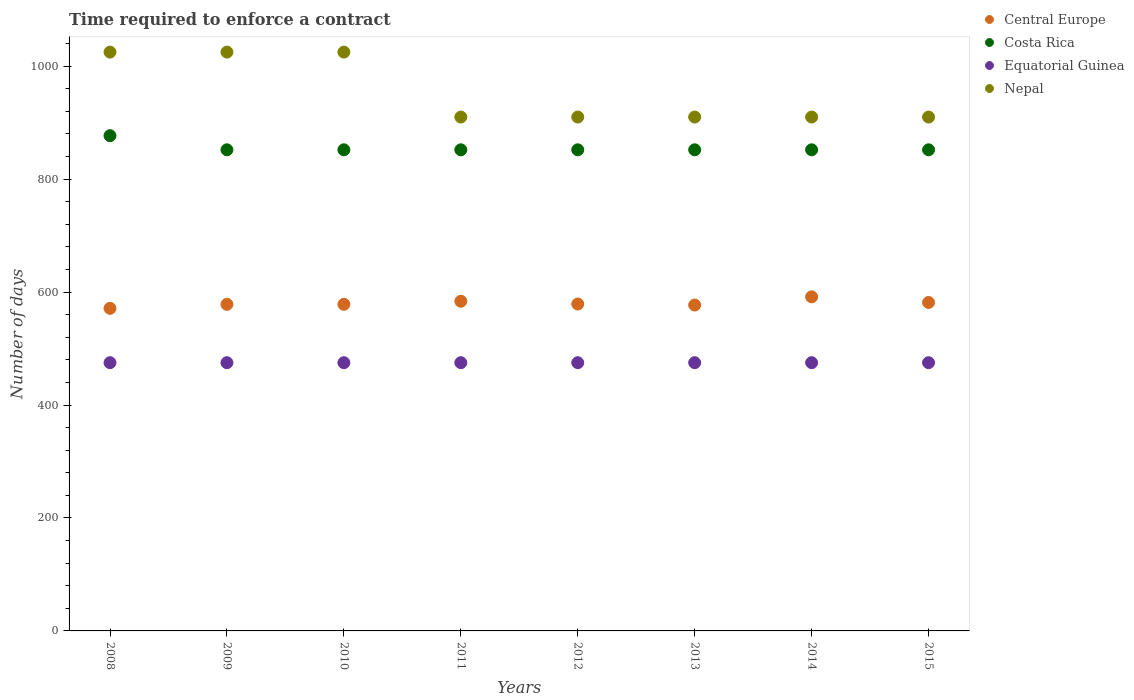How many different coloured dotlines are there?
Give a very brief answer. 4. Is the number of dotlines equal to the number of legend labels?
Keep it short and to the point. Yes. What is the number of days required to enforce a contract in Nepal in 2008?
Make the answer very short. 1025. Across all years, what is the maximum number of days required to enforce a contract in Nepal?
Provide a short and direct response. 1025. Across all years, what is the minimum number of days required to enforce a contract in Nepal?
Keep it short and to the point. 910. What is the total number of days required to enforce a contract in Equatorial Guinea in the graph?
Make the answer very short. 3800. What is the difference between the number of days required to enforce a contract in Costa Rica in 2012 and the number of days required to enforce a contract in Nepal in 2008?
Make the answer very short. -173. What is the average number of days required to enforce a contract in Equatorial Guinea per year?
Offer a terse response. 475. In the year 2015, what is the difference between the number of days required to enforce a contract in Central Europe and number of days required to enforce a contract in Costa Rica?
Your answer should be very brief. -270.36. In how many years, is the number of days required to enforce a contract in Nepal greater than 520 days?
Provide a short and direct response. 8. What is the ratio of the number of days required to enforce a contract in Central Europe in 2010 to that in 2012?
Provide a short and direct response. 1. What is the difference between the highest and the second highest number of days required to enforce a contract in Costa Rica?
Your answer should be compact. 25. What is the difference between the highest and the lowest number of days required to enforce a contract in Nepal?
Offer a terse response. 115. In how many years, is the number of days required to enforce a contract in Costa Rica greater than the average number of days required to enforce a contract in Costa Rica taken over all years?
Provide a short and direct response. 1. Is it the case that in every year, the sum of the number of days required to enforce a contract in Equatorial Guinea and number of days required to enforce a contract in Nepal  is greater than the number of days required to enforce a contract in Central Europe?
Your answer should be compact. Yes. Does the number of days required to enforce a contract in Central Europe monotonically increase over the years?
Make the answer very short. No. Is the number of days required to enforce a contract in Central Europe strictly greater than the number of days required to enforce a contract in Equatorial Guinea over the years?
Ensure brevity in your answer.  Yes. Is the number of days required to enforce a contract in Costa Rica strictly less than the number of days required to enforce a contract in Equatorial Guinea over the years?
Give a very brief answer. No. How many dotlines are there?
Make the answer very short. 4. What is the difference between two consecutive major ticks on the Y-axis?
Make the answer very short. 200. Where does the legend appear in the graph?
Give a very brief answer. Top right. How many legend labels are there?
Give a very brief answer. 4. How are the legend labels stacked?
Your answer should be very brief. Vertical. What is the title of the graph?
Give a very brief answer. Time required to enforce a contract. Does "New Zealand" appear as one of the legend labels in the graph?
Keep it short and to the point. No. What is the label or title of the Y-axis?
Your response must be concise. Number of days. What is the Number of days in Central Europe in 2008?
Offer a very short reply. 571.27. What is the Number of days in Costa Rica in 2008?
Make the answer very short. 877. What is the Number of days of Equatorial Guinea in 2008?
Provide a succinct answer. 475. What is the Number of days of Nepal in 2008?
Your response must be concise. 1025. What is the Number of days in Central Europe in 2009?
Provide a succinct answer. 578.36. What is the Number of days in Costa Rica in 2009?
Your response must be concise. 852. What is the Number of days in Equatorial Guinea in 2009?
Give a very brief answer. 475. What is the Number of days of Nepal in 2009?
Give a very brief answer. 1025. What is the Number of days of Central Europe in 2010?
Give a very brief answer. 578.36. What is the Number of days of Costa Rica in 2010?
Offer a very short reply. 852. What is the Number of days in Equatorial Guinea in 2010?
Your answer should be compact. 475. What is the Number of days in Nepal in 2010?
Keep it short and to the point. 1025. What is the Number of days of Central Europe in 2011?
Offer a very short reply. 583.82. What is the Number of days of Costa Rica in 2011?
Ensure brevity in your answer.  852. What is the Number of days of Equatorial Guinea in 2011?
Your answer should be very brief. 475. What is the Number of days in Nepal in 2011?
Offer a very short reply. 910. What is the Number of days of Central Europe in 2012?
Keep it short and to the point. 578.91. What is the Number of days in Costa Rica in 2012?
Provide a succinct answer. 852. What is the Number of days in Equatorial Guinea in 2012?
Keep it short and to the point. 475. What is the Number of days of Nepal in 2012?
Make the answer very short. 910. What is the Number of days in Central Europe in 2013?
Keep it short and to the point. 577.09. What is the Number of days in Costa Rica in 2013?
Give a very brief answer. 852. What is the Number of days of Equatorial Guinea in 2013?
Your answer should be compact. 475. What is the Number of days of Nepal in 2013?
Your answer should be very brief. 910. What is the Number of days in Central Europe in 2014?
Offer a very short reply. 591.64. What is the Number of days in Costa Rica in 2014?
Ensure brevity in your answer.  852. What is the Number of days in Equatorial Guinea in 2014?
Provide a succinct answer. 475. What is the Number of days of Nepal in 2014?
Provide a short and direct response. 910. What is the Number of days in Central Europe in 2015?
Your answer should be very brief. 581.64. What is the Number of days in Costa Rica in 2015?
Keep it short and to the point. 852. What is the Number of days of Equatorial Guinea in 2015?
Provide a succinct answer. 475. What is the Number of days of Nepal in 2015?
Your answer should be very brief. 910. Across all years, what is the maximum Number of days in Central Europe?
Your answer should be very brief. 591.64. Across all years, what is the maximum Number of days of Costa Rica?
Offer a terse response. 877. Across all years, what is the maximum Number of days of Equatorial Guinea?
Provide a short and direct response. 475. Across all years, what is the maximum Number of days of Nepal?
Your response must be concise. 1025. Across all years, what is the minimum Number of days of Central Europe?
Provide a short and direct response. 571.27. Across all years, what is the minimum Number of days in Costa Rica?
Make the answer very short. 852. Across all years, what is the minimum Number of days in Equatorial Guinea?
Your answer should be compact. 475. Across all years, what is the minimum Number of days of Nepal?
Provide a succinct answer. 910. What is the total Number of days of Central Europe in the graph?
Ensure brevity in your answer.  4641.09. What is the total Number of days in Costa Rica in the graph?
Ensure brevity in your answer.  6841. What is the total Number of days in Equatorial Guinea in the graph?
Your answer should be very brief. 3800. What is the total Number of days in Nepal in the graph?
Keep it short and to the point. 7625. What is the difference between the Number of days in Central Europe in 2008 and that in 2009?
Your response must be concise. -7.09. What is the difference between the Number of days of Equatorial Guinea in 2008 and that in 2009?
Your answer should be very brief. 0. What is the difference between the Number of days in Central Europe in 2008 and that in 2010?
Make the answer very short. -7.09. What is the difference between the Number of days in Costa Rica in 2008 and that in 2010?
Give a very brief answer. 25. What is the difference between the Number of days of Equatorial Guinea in 2008 and that in 2010?
Offer a very short reply. 0. What is the difference between the Number of days in Central Europe in 2008 and that in 2011?
Keep it short and to the point. -12.55. What is the difference between the Number of days in Costa Rica in 2008 and that in 2011?
Your response must be concise. 25. What is the difference between the Number of days in Equatorial Guinea in 2008 and that in 2011?
Make the answer very short. 0. What is the difference between the Number of days of Nepal in 2008 and that in 2011?
Provide a succinct answer. 115. What is the difference between the Number of days in Central Europe in 2008 and that in 2012?
Offer a terse response. -7.64. What is the difference between the Number of days in Costa Rica in 2008 and that in 2012?
Provide a short and direct response. 25. What is the difference between the Number of days of Nepal in 2008 and that in 2012?
Your answer should be very brief. 115. What is the difference between the Number of days of Central Europe in 2008 and that in 2013?
Provide a succinct answer. -5.82. What is the difference between the Number of days of Equatorial Guinea in 2008 and that in 2013?
Ensure brevity in your answer.  0. What is the difference between the Number of days of Nepal in 2008 and that in 2013?
Keep it short and to the point. 115. What is the difference between the Number of days in Central Europe in 2008 and that in 2014?
Your answer should be compact. -20.36. What is the difference between the Number of days in Costa Rica in 2008 and that in 2014?
Offer a terse response. 25. What is the difference between the Number of days of Equatorial Guinea in 2008 and that in 2014?
Your response must be concise. 0. What is the difference between the Number of days in Nepal in 2008 and that in 2014?
Make the answer very short. 115. What is the difference between the Number of days in Central Europe in 2008 and that in 2015?
Offer a terse response. -10.36. What is the difference between the Number of days of Costa Rica in 2008 and that in 2015?
Provide a succinct answer. 25. What is the difference between the Number of days in Equatorial Guinea in 2008 and that in 2015?
Offer a terse response. 0. What is the difference between the Number of days of Nepal in 2008 and that in 2015?
Your response must be concise. 115. What is the difference between the Number of days in Costa Rica in 2009 and that in 2010?
Your answer should be very brief. 0. What is the difference between the Number of days of Central Europe in 2009 and that in 2011?
Keep it short and to the point. -5.45. What is the difference between the Number of days in Equatorial Guinea in 2009 and that in 2011?
Provide a succinct answer. 0. What is the difference between the Number of days in Nepal in 2009 and that in 2011?
Your answer should be compact. 115. What is the difference between the Number of days of Central Europe in 2009 and that in 2012?
Provide a short and direct response. -0.55. What is the difference between the Number of days in Costa Rica in 2009 and that in 2012?
Make the answer very short. 0. What is the difference between the Number of days of Nepal in 2009 and that in 2012?
Ensure brevity in your answer.  115. What is the difference between the Number of days in Central Europe in 2009 and that in 2013?
Your answer should be compact. 1.27. What is the difference between the Number of days of Nepal in 2009 and that in 2013?
Provide a succinct answer. 115. What is the difference between the Number of days in Central Europe in 2009 and that in 2014?
Offer a very short reply. -13.27. What is the difference between the Number of days of Costa Rica in 2009 and that in 2014?
Offer a very short reply. 0. What is the difference between the Number of days in Equatorial Guinea in 2009 and that in 2014?
Your response must be concise. 0. What is the difference between the Number of days in Nepal in 2009 and that in 2014?
Provide a short and direct response. 115. What is the difference between the Number of days in Central Europe in 2009 and that in 2015?
Your answer should be compact. -3.27. What is the difference between the Number of days of Equatorial Guinea in 2009 and that in 2015?
Give a very brief answer. 0. What is the difference between the Number of days of Nepal in 2009 and that in 2015?
Provide a short and direct response. 115. What is the difference between the Number of days of Central Europe in 2010 and that in 2011?
Offer a very short reply. -5.45. What is the difference between the Number of days of Costa Rica in 2010 and that in 2011?
Provide a short and direct response. 0. What is the difference between the Number of days of Equatorial Guinea in 2010 and that in 2011?
Make the answer very short. 0. What is the difference between the Number of days of Nepal in 2010 and that in 2011?
Your response must be concise. 115. What is the difference between the Number of days in Central Europe in 2010 and that in 2012?
Offer a terse response. -0.55. What is the difference between the Number of days in Nepal in 2010 and that in 2012?
Offer a terse response. 115. What is the difference between the Number of days of Central Europe in 2010 and that in 2013?
Offer a terse response. 1.27. What is the difference between the Number of days in Nepal in 2010 and that in 2013?
Provide a succinct answer. 115. What is the difference between the Number of days of Central Europe in 2010 and that in 2014?
Offer a very short reply. -13.27. What is the difference between the Number of days in Costa Rica in 2010 and that in 2014?
Your answer should be very brief. 0. What is the difference between the Number of days of Nepal in 2010 and that in 2014?
Keep it short and to the point. 115. What is the difference between the Number of days of Central Europe in 2010 and that in 2015?
Offer a terse response. -3.27. What is the difference between the Number of days of Nepal in 2010 and that in 2015?
Offer a very short reply. 115. What is the difference between the Number of days of Central Europe in 2011 and that in 2012?
Keep it short and to the point. 4.91. What is the difference between the Number of days of Equatorial Guinea in 2011 and that in 2012?
Give a very brief answer. 0. What is the difference between the Number of days in Nepal in 2011 and that in 2012?
Give a very brief answer. 0. What is the difference between the Number of days in Central Europe in 2011 and that in 2013?
Your answer should be compact. 6.73. What is the difference between the Number of days in Costa Rica in 2011 and that in 2013?
Give a very brief answer. 0. What is the difference between the Number of days in Equatorial Guinea in 2011 and that in 2013?
Your response must be concise. 0. What is the difference between the Number of days in Central Europe in 2011 and that in 2014?
Offer a very short reply. -7.82. What is the difference between the Number of days in Costa Rica in 2011 and that in 2014?
Offer a very short reply. 0. What is the difference between the Number of days in Equatorial Guinea in 2011 and that in 2014?
Your answer should be very brief. 0. What is the difference between the Number of days of Nepal in 2011 and that in 2014?
Offer a very short reply. 0. What is the difference between the Number of days of Central Europe in 2011 and that in 2015?
Give a very brief answer. 2.18. What is the difference between the Number of days in Costa Rica in 2011 and that in 2015?
Make the answer very short. 0. What is the difference between the Number of days of Nepal in 2011 and that in 2015?
Your answer should be very brief. 0. What is the difference between the Number of days of Central Europe in 2012 and that in 2013?
Your answer should be compact. 1.82. What is the difference between the Number of days of Costa Rica in 2012 and that in 2013?
Your answer should be compact. 0. What is the difference between the Number of days of Equatorial Guinea in 2012 and that in 2013?
Provide a short and direct response. 0. What is the difference between the Number of days of Central Europe in 2012 and that in 2014?
Keep it short and to the point. -12.73. What is the difference between the Number of days in Costa Rica in 2012 and that in 2014?
Provide a short and direct response. 0. What is the difference between the Number of days in Nepal in 2012 and that in 2014?
Provide a succinct answer. 0. What is the difference between the Number of days in Central Europe in 2012 and that in 2015?
Your response must be concise. -2.73. What is the difference between the Number of days in Central Europe in 2013 and that in 2014?
Your response must be concise. -14.55. What is the difference between the Number of days of Costa Rica in 2013 and that in 2014?
Ensure brevity in your answer.  0. What is the difference between the Number of days in Central Europe in 2013 and that in 2015?
Provide a succinct answer. -4.55. What is the difference between the Number of days of Costa Rica in 2013 and that in 2015?
Your answer should be very brief. 0. What is the difference between the Number of days in Nepal in 2013 and that in 2015?
Ensure brevity in your answer.  0. What is the difference between the Number of days in Central Europe in 2014 and that in 2015?
Your answer should be compact. 10. What is the difference between the Number of days of Costa Rica in 2014 and that in 2015?
Keep it short and to the point. 0. What is the difference between the Number of days of Equatorial Guinea in 2014 and that in 2015?
Your answer should be compact. 0. What is the difference between the Number of days of Central Europe in 2008 and the Number of days of Costa Rica in 2009?
Make the answer very short. -280.73. What is the difference between the Number of days in Central Europe in 2008 and the Number of days in Equatorial Guinea in 2009?
Provide a succinct answer. 96.27. What is the difference between the Number of days in Central Europe in 2008 and the Number of days in Nepal in 2009?
Your answer should be compact. -453.73. What is the difference between the Number of days in Costa Rica in 2008 and the Number of days in Equatorial Guinea in 2009?
Give a very brief answer. 402. What is the difference between the Number of days in Costa Rica in 2008 and the Number of days in Nepal in 2009?
Your response must be concise. -148. What is the difference between the Number of days in Equatorial Guinea in 2008 and the Number of days in Nepal in 2009?
Provide a short and direct response. -550. What is the difference between the Number of days of Central Europe in 2008 and the Number of days of Costa Rica in 2010?
Provide a succinct answer. -280.73. What is the difference between the Number of days in Central Europe in 2008 and the Number of days in Equatorial Guinea in 2010?
Your response must be concise. 96.27. What is the difference between the Number of days in Central Europe in 2008 and the Number of days in Nepal in 2010?
Your answer should be very brief. -453.73. What is the difference between the Number of days of Costa Rica in 2008 and the Number of days of Equatorial Guinea in 2010?
Provide a succinct answer. 402. What is the difference between the Number of days in Costa Rica in 2008 and the Number of days in Nepal in 2010?
Your response must be concise. -148. What is the difference between the Number of days in Equatorial Guinea in 2008 and the Number of days in Nepal in 2010?
Ensure brevity in your answer.  -550. What is the difference between the Number of days in Central Europe in 2008 and the Number of days in Costa Rica in 2011?
Provide a succinct answer. -280.73. What is the difference between the Number of days in Central Europe in 2008 and the Number of days in Equatorial Guinea in 2011?
Offer a terse response. 96.27. What is the difference between the Number of days in Central Europe in 2008 and the Number of days in Nepal in 2011?
Your answer should be very brief. -338.73. What is the difference between the Number of days in Costa Rica in 2008 and the Number of days in Equatorial Guinea in 2011?
Your answer should be compact. 402. What is the difference between the Number of days in Costa Rica in 2008 and the Number of days in Nepal in 2011?
Provide a succinct answer. -33. What is the difference between the Number of days in Equatorial Guinea in 2008 and the Number of days in Nepal in 2011?
Give a very brief answer. -435. What is the difference between the Number of days in Central Europe in 2008 and the Number of days in Costa Rica in 2012?
Ensure brevity in your answer.  -280.73. What is the difference between the Number of days in Central Europe in 2008 and the Number of days in Equatorial Guinea in 2012?
Offer a terse response. 96.27. What is the difference between the Number of days in Central Europe in 2008 and the Number of days in Nepal in 2012?
Your answer should be compact. -338.73. What is the difference between the Number of days in Costa Rica in 2008 and the Number of days in Equatorial Guinea in 2012?
Make the answer very short. 402. What is the difference between the Number of days in Costa Rica in 2008 and the Number of days in Nepal in 2012?
Your answer should be compact. -33. What is the difference between the Number of days in Equatorial Guinea in 2008 and the Number of days in Nepal in 2012?
Offer a very short reply. -435. What is the difference between the Number of days in Central Europe in 2008 and the Number of days in Costa Rica in 2013?
Offer a very short reply. -280.73. What is the difference between the Number of days in Central Europe in 2008 and the Number of days in Equatorial Guinea in 2013?
Provide a succinct answer. 96.27. What is the difference between the Number of days in Central Europe in 2008 and the Number of days in Nepal in 2013?
Keep it short and to the point. -338.73. What is the difference between the Number of days in Costa Rica in 2008 and the Number of days in Equatorial Guinea in 2013?
Give a very brief answer. 402. What is the difference between the Number of days in Costa Rica in 2008 and the Number of days in Nepal in 2013?
Your answer should be very brief. -33. What is the difference between the Number of days of Equatorial Guinea in 2008 and the Number of days of Nepal in 2013?
Give a very brief answer. -435. What is the difference between the Number of days in Central Europe in 2008 and the Number of days in Costa Rica in 2014?
Your answer should be very brief. -280.73. What is the difference between the Number of days in Central Europe in 2008 and the Number of days in Equatorial Guinea in 2014?
Offer a terse response. 96.27. What is the difference between the Number of days of Central Europe in 2008 and the Number of days of Nepal in 2014?
Give a very brief answer. -338.73. What is the difference between the Number of days in Costa Rica in 2008 and the Number of days in Equatorial Guinea in 2014?
Your response must be concise. 402. What is the difference between the Number of days in Costa Rica in 2008 and the Number of days in Nepal in 2014?
Your answer should be very brief. -33. What is the difference between the Number of days in Equatorial Guinea in 2008 and the Number of days in Nepal in 2014?
Give a very brief answer. -435. What is the difference between the Number of days of Central Europe in 2008 and the Number of days of Costa Rica in 2015?
Ensure brevity in your answer.  -280.73. What is the difference between the Number of days of Central Europe in 2008 and the Number of days of Equatorial Guinea in 2015?
Your answer should be compact. 96.27. What is the difference between the Number of days of Central Europe in 2008 and the Number of days of Nepal in 2015?
Provide a succinct answer. -338.73. What is the difference between the Number of days in Costa Rica in 2008 and the Number of days in Equatorial Guinea in 2015?
Your answer should be compact. 402. What is the difference between the Number of days in Costa Rica in 2008 and the Number of days in Nepal in 2015?
Provide a succinct answer. -33. What is the difference between the Number of days of Equatorial Guinea in 2008 and the Number of days of Nepal in 2015?
Make the answer very short. -435. What is the difference between the Number of days in Central Europe in 2009 and the Number of days in Costa Rica in 2010?
Your response must be concise. -273.64. What is the difference between the Number of days of Central Europe in 2009 and the Number of days of Equatorial Guinea in 2010?
Offer a terse response. 103.36. What is the difference between the Number of days of Central Europe in 2009 and the Number of days of Nepal in 2010?
Provide a succinct answer. -446.64. What is the difference between the Number of days in Costa Rica in 2009 and the Number of days in Equatorial Guinea in 2010?
Your answer should be very brief. 377. What is the difference between the Number of days of Costa Rica in 2009 and the Number of days of Nepal in 2010?
Your answer should be compact. -173. What is the difference between the Number of days in Equatorial Guinea in 2009 and the Number of days in Nepal in 2010?
Your answer should be very brief. -550. What is the difference between the Number of days in Central Europe in 2009 and the Number of days in Costa Rica in 2011?
Provide a short and direct response. -273.64. What is the difference between the Number of days in Central Europe in 2009 and the Number of days in Equatorial Guinea in 2011?
Provide a succinct answer. 103.36. What is the difference between the Number of days of Central Europe in 2009 and the Number of days of Nepal in 2011?
Offer a very short reply. -331.64. What is the difference between the Number of days in Costa Rica in 2009 and the Number of days in Equatorial Guinea in 2011?
Provide a succinct answer. 377. What is the difference between the Number of days of Costa Rica in 2009 and the Number of days of Nepal in 2011?
Provide a short and direct response. -58. What is the difference between the Number of days of Equatorial Guinea in 2009 and the Number of days of Nepal in 2011?
Give a very brief answer. -435. What is the difference between the Number of days in Central Europe in 2009 and the Number of days in Costa Rica in 2012?
Your response must be concise. -273.64. What is the difference between the Number of days of Central Europe in 2009 and the Number of days of Equatorial Guinea in 2012?
Provide a short and direct response. 103.36. What is the difference between the Number of days in Central Europe in 2009 and the Number of days in Nepal in 2012?
Offer a very short reply. -331.64. What is the difference between the Number of days of Costa Rica in 2009 and the Number of days of Equatorial Guinea in 2012?
Provide a succinct answer. 377. What is the difference between the Number of days of Costa Rica in 2009 and the Number of days of Nepal in 2012?
Your response must be concise. -58. What is the difference between the Number of days in Equatorial Guinea in 2009 and the Number of days in Nepal in 2012?
Give a very brief answer. -435. What is the difference between the Number of days in Central Europe in 2009 and the Number of days in Costa Rica in 2013?
Your response must be concise. -273.64. What is the difference between the Number of days in Central Europe in 2009 and the Number of days in Equatorial Guinea in 2013?
Your answer should be compact. 103.36. What is the difference between the Number of days in Central Europe in 2009 and the Number of days in Nepal in 2013?
Ensure brevity in your answer.  -331.64. What is the difference between the Number of days of Costa Rica in 2009 and the Number of days of Equatorial Guinea in 2013?
Offer a very short reply. 377. What is the difference between the Number of days in Costa Rica in 2009 and the Number of days in Nepal in 2013?
Ensure brevity in your answer.  -58. What is the difference between the Number of days in Equatorial Guinea in 2009 and the Number of days in Nepal in 2013?
Your response must be concise. -435. What is the difference between the Number of days in Central Europe in 2009 and the Number of days in Costa Rica in 2014?
Make the answer very short. -273.64. What is the difference between the Number of days in Central Europe in 2009 and the Number of days in Equatorial Guinea in 2014?
Give a very brief answer. 103.36. What is the difference between the Number of days in Central Europe in 2009 and the Number of days in Nepal in 2014?
Your answer should be very brief. -331.64. What is the difference between the Number of days of Costa Rica in 2009 and the Number of days of Equatorial Guinea in 2014?
Offer a very short reply. 377. What is the difference between the Number of days in Costa Rica in 2009 and the Number of days in Nepal in 2014?
Provide a short and direct response. -58. What is the difference between the Number of days of Equatorial Guinea in 2009 and the Number of days of Nepal in 2014?
Offer a terse response. -435. What is the difference between the Number of days of Central Europe in 2009 and the Number of days of Costa Rica in 2015?
Give a very brief answer. -273.64. What is the difference between the Number of days of Central Europe in 2009 and the Number of days of Equatorial Guinea in 2015?
Ensure brevity in your answer.  103.36. What is the difference between the Number of days in Central Europe in 2009 and the Number of days in Nepal in 2015?
Give a very brief answer. -331.64. What is the difference between the Number of days of Costa Rica in 2009 and the Number of days of Equatorial Guinea in 2015?
Your response must be concise. 377. What is the difference between the Number of days of Costa Rica in 2009 and the Number of days of Nepal in 2015?
Your answer should be very brief. -58. What is the difference between the Number of days in Equatorial Guinea in 2009 and the Number of days in Nepal in 2015?
Offer a terse response. -435. What is the difference between the Number of days of Central Europe in 2010 and the Number of days of Costa Rica in 2011?
Offer a very short reply. -273.64. What is the difference between the Number of days of Central Europe in 2010 and the Number of days of Equatorial Guinea in 2011?
Give a very brief answer. 103.36. What is the difference between the Number of days in Central Europe in 2010 and the Number of days in Nepal in 2011?
Your response must be concise. -331.64. What is the difference between the Number of days of Costa Rica in 2010 and the Number of days of Equatorial Guinea in 2011?
Your response must be concise. 377. What is the difference between the Number of days of Costa Rica in 2010 and the Number of days of Nepal in 2011?
Offer a terse response. -58. What is the difference between the Number of days in Equatorial Guinea in 2010 and the Number of days in Nepal in 2011?
Make the answer very short. -435. What is the difference between the Number of days in Central Europe in 2010 and the Number of days in Costa Rica in 2012?
Make the answer very short. -273.64. What is the difference between the Number of days of Central Europe in 2010 and the Number of days of Equatorial Guinea in 2012?
Your response must be concise. 103.36. What is the difference between the Number of days of Central Europe in 2010 and the Number of days of Nepal in 2012?
Ensure brevity in your answer.  -331.64. What is the difference between the Number of days in Costa Rica in 2010 and the Number of days in Equatorial Guinea in 2012?
Offer a terse response. 377. What is the difference between the Number of days in Costa Rica in 2010 and the Number of days in Nepal in 2012?
Your answer should be compact. -58. What is the difference between the Number of days of Equatorial Guinea in 2010 and the Number of days of Nepal in 2012?
Ensure brevity in your answer.  -435. What is the difference between the Number of days in Central Europe in 2010 and the Number of days in Costa Rica in 2013?
Your answer should be very brief. -273.64. What is the difference between the Number of days in Central Europe in 2010 and the Number of days in Equatorial Guinea in 2013?
Offer a very short reply. 103.36. What is the difference between the Number of days in Central Europe in 2010 and the Number of days in Nepal in 2013?
Your answer should be compact. -331.64. What is the difference between the Number of days in Costa Rica in 2010 and the Number of days in Equatorial Guinea in 2013?
Provide a short and direct response. 377. What is the difference between the Number of days of Costa Rica in 2010 and the Number of days of Nepal in 2013?
Provide a short and direct response. -58. What is the difference between the Number of days in Equatorial Guinea in 2010 and the Number of days in Nepal in 2013?
Provide a short and direct response. -435. What is the difference between the Number of days of Central Europe in 2010 and the Number of days of Costa Rica in 2014?
Give a very brief answer. -273.64. What is the difference between the Number of days of Central Europe in 2010 and the Number of days of Equatorial Guinea in 2014?
Give a very brief answer. 103.36. What is the difference between the Number of days in Central Europe in 2010 and the Number of days in Nepal in 2014?
Offer a very short reply. -331.64. What is the difference between the Number of days in Costa Rica in 2010 and the Number of days in Equatorial Guinea in 2014?
Your answer should be very brief. 377. What is the difference between the Number of days of Costa Rica in 2010 and the Number of days of Nepal in 2014?
Offer a terse response. -58. What is the difference between the Number of days in Equatorial Guinea in 2010 and the Number of days in Nepal in 2014?
Give a very brief answer. -435. What is the difference between the Number of days of Central Europe in 2010 and the Number of days of Costa Rica in 2015?
Provide a succinct answer. -273.64. What is the difference between the Number of days of Central Europe in 2010 and the Number of days of Equatorial Guinea in 2015?
Your answer should be very brief. 103.36. What is the difference between the Number of days in Central Europe in 2010 and the Number of days in Nepal in 2015?
Offer a terse response. -331.64. What is the difference between the Number of days of Costa Rica in 2010 and the Number of days of Equatorial Guinea in 2015?
Ensure brevity in your answer.  377. What is the difference between the Number of days in Costa Rica in 2010 and the Number of days in Nepal in 2015?
Your answer should be compact. -58. What is the difference between the Number of days of Equatorial Guinea in 2010 and the Number of days of Nepal in 2015?
Give a very brief answer. -435. What is the difference between the Number of days in Central Europe in 2011 and the Number of days in Costa Rica in 2012?
Make the answer very short. -268.18. What is the difference between the Number of days of Central Europe in 2011 and the Number of days of Equatorial Guinea in 2012?
Keep it short and to the point. 108.82. What is the difference between the Number of days in Central Europe in 2011 and the Number of days in Nepal in 2012?
Your answer should be compact. -326.18. What is the difference between the Number of days of Costa Rica in 2011 and the Number of days of Equatorial Guinea in 2012?
Make the answer very short. 377. What is the difference between the Number of days in Costa Rica in 2011 and the Number of days in Nepal in 2012?
Offer a very short reply. -58. What is the difference between the Number of days of Equatorial Guinea in 2011 and the Number of days of Nepal in 2012?
Ensure brevity in your answer.  -435. What is the difference between the Number of days of Central Europe in 2011 and the Number of days of Costa Rica in 2013?
Provide a succinct answer. -268.18. What is the difference between the Number of days in Central Europe in 2011 and the Number of days in Equatorial Guinea in 2013?
Make the answer very short. 108.82. What is the difference between the Number of days of Central Europe in 2011 and the Number of days of Nepal in 2013?
Provide a short and direct response. -326.18. What is the difference between the Number of days of Costa Rica in 2011 and the Number of days of Equatorial Guinea in 2013?
Ensure brevity in your answer.  377. What is the difference between the Number of days of Costa Rica in 2011 and the Number of days of Nepal in 2013?
Give a very brief answer. -58. What is the difference between the Number of days in Equatorial Guinea in 2011 and the Number of days in Nepal in 2013?
Your answer should be compact. -435. What is the difference between the Number of days in Central Europe in 2011 and the Number of days in Costa Rica in 2014?
Ensure brevity in your answer.  -268.18. What is the difference between the Number of days of Central Europe in 2011 and the Number of days of Equatorial Guinea in 2014?
Offer a very short reply. 108.82. What is the difference between the Number of days in Central Europe in 2011 and the Number of days in Nepal in 2014?
Make the answer very short. -326.18. What is the difference between the Number of days in Costa Rica in 2011 and the Number of days in Equatorial Guinea in 2014?
Make the answer very short. 377. What is the difference between the Number of days in Costa Rica in 2011 and the Number of days in Nepal in 2014?
Your answer should be very brief. -58. What is the difference between the Number of days of Equatorial Guinea in 2011 and the Number of days of Nepal in 2014?
Provide a succinct answer. -435. What is the difference between the Number of days of Central Europe in 2011 and the Number of days of Costa Rica in 2015?
Provide a succinct answer. -268.18. What is the difference between the Number of days in Central Europe in 2011 and the Number of days in Equatorial Guinea in 2015?
Give a very brief answer. 108.82. What is the difference between the Number of days in Central Europe in 2011 and the Number of days in Nepal in 2015?
Offer a terse response. -326.18. What is the difference between the Number of days in Costa Rica in 2011 and the Number of days in Equatorial Guinea in 2015?
Offer a terse response. 377. What is the difference between the Number of days in Costa Rica in 2011 and the Number of days in Nepal in 2015?
Provide a short and direct response. -58. What is the difference between the Number of days in Equatorial Guinea in 2011 and the Number of days in Nepal in 2015?
Make the answer very short. -435. What is the difference between the Number of days in Central Europe in 2012 and the Number of days in Costa Rica in 2013?
Give a very brief answer. -273.09. What is the difference between the Number of days in Central Europe in 2012 and the Number of days in Equatorial Guinea in 2013?
Your answer should be compact. 103.91. What is the difference between the Number of days in Central Europe in 2012 and the Number of days in Nepal in 2013?
Provide a succinct answer. -331.09. What is the difference between the Number of days in Costa Rica in 2012 and the Number of days in Equatorial Guinea in 2013?
Give a very brief answer. 377. What is the difference between the Number of days in Costa Rica in 2012 and the Number of days in Nepal in 2013?
Provide a short and direct response. -58. What is the difference between the Number of days of Equatorial Guinea in 2012 and the Number of days of Nepal in 2013?
Keep it short and to the point. -435. What is the difference between the Number of days in Central Europe in 2012 and the Number of days in Costa Rica in 2014?
Provide a short and direct response. -273.09. What is the difference between the Number of days in Central Europe in 2012 and the Number of days in Equatorial Guinea in 2014?
Make the answer very short. 103.91. What is the difference between the Number of days of Central Europe in 2012 and the Number of days of Nepal in 2014?
Provide a short and direct response. -331.09. What is the difference between the Number of days of Costa Rica in 2012 and the Number of days of Equatorial Guinea in 2014?
Your answer should be compact. 377. What is the difference between the Number of days in Costa Rica in 2012 and the Number of days in Nepal in 2014?
Give a very brief answer. -58. What is the difference between the Number of days in Equatorial Guinea in 2012 and the Number of days in Nepal in 2014?
Provide a short and direct response. -435. What is the difference between the Number of days of Central Europe in 2012 and the Number of days of Costa Rica in 2015?
Offer a very short reply. -273.09. What is the difference between the Number of days of Central Europe in 2012 and the Number of days of Equatorial Guinea in 2015?
Provide a succinct answer. 103.91. What is the difference between the Number of days of Central Europe in 2012 and the Number of days of Nepal in 2015?
Make the answer very short. -331.09. What is the difference between the Number of days of Costa Rica in 2012 and the Number of days of Equatorial Guinea in 2015?
Keep it short and to the point. 377. What is the difference between the Number of days of Costa Rica in 2012 and the Number of days of Nepal in 2015?
Ensure brevity in your answer.  -58. What is the difference between the Number of days of Equatorial Guinea in 2012 and the Number of days of Nepal in 2015?
Make the answer very short. -435. What is the difference between the Number of days of Central Europe in 2013 and the Number of days of Costa Rica in 2014?
Provide a succinct answer. -274.91. What is the difference between the Number of days in Central Europe in 2013 and the Number of days in Equatorial Guinea in 2014?
Ensure brevity in your answer.  102.09. What is the difference between the Number of days of Central Europe in 2013 and the Number of days of Nepal in 2014?
Give a very brief answer. -332.91. What is the difference between the Number of days in Costa Rica in 2013 and the Number of days in Equatorial Guinea in 2014?
Offer a very short reply. 377. What is the difference between the Number of days of Costa Rica in 2013 and the Number of days of Nepal in 2014?
Keep it short and to the point. -58. What is the difference between the Number of days in Equatorial Guinea in 2013 and the Number of days in Nepal in 2014?
Make the answer very short. -435. What is the difference between the Number of days in Central Europe in 2013 and the Number of days in Costa Rica in 2015?
Provide a short and direct response. -274.91. What is the difference between the Number of days in Central Europe in 2013 and the Number of days in Equatorial Guinea in 2015?
Ensure brevity in your answer.  102.09. What is the difference between the Number of days of Central Europe in 2013 and the Number of days of Nepal in 2015?
Offer a very short reply. -332.91. What is the difference between the Number of days in Costa Rica in 2013 and the Number of days in Equatorial Guinea in 2015?
Your answer should be compact. 377. What is the difference between the Number of days in Costa Rica in 2013 and the Number of days in Nepal in 2015?
Your response must be concise. -58. What is the difference between the Number of days of Equatorial Guinea in 2013 and the Number of days of Nepal in 2015?
Your response must be concise. -435. What is the difference between the Number of days of Central Europe in 2014 and the Number of days of Costa Rica in 2015?
Your answer should be compact. -260.36. What is the difference between the Number of days of Central Europe in 2014 and the Number of days of Equatorial Guinea in 2015?
Provide a succinct answer. 116.64. What is the difference between the Number of days in Central Europe in 2014 and the Number of days in Nepal in 2015?
Your answer should be compact. -318.36. What is the difference between the Number of days in Costa Rica in 2014 and the Number of days in Equatorial Guinea in 2015?
Your response must be concise. 377. What is the difference between the Number of days of Costa Rica in 2014 and the Number of days of Nepal in 2015?
Make the answer very short. -58. What is the difference between the Number of days of Equatorial Guinea in 2014 and the Number of days of Nepal in 2015?
Offer a terse response. -435. What is the average Number of days of Central Europe per year?
Provide a succinct answer. 580.14. What is the average Number of days in Costa Rica per year?
Your response must be concise. 855.12. What is the average Number of days of Equatorial Guinea per year?
Provide a succinct answer. 475. What is the average Number of days in Nepal per year?
Your response must be concise. 953.12. In the year 2008, what is the difference between the Number of days of Central Europe and Number of days of Costa Rica?
Give a very brief answer. -305.73. In the year 2008, what is the difference between the Number of days of Central Europe and Number of days of Equatorial Guinea?
Your response must be concise. 96.27. In the year 2008, what is the difference between the Number of days of Central Europe and Number of days of Nepal?
Your response must be concise. -453.73. In the year 2008, what is the difference between the Number of days in Costa Rica and Number of days in Equatorial Guinea?
Your answer should be very brief. 402. In the year 2008, what is the difference between the Number of days of Costa Rica and Number of days of Nepal?
Your response must be concise. -148. In the year 2008, what is the difference between the Number of days in Equatorial Guinea and Number of days in Nepal?
Your answer should be very brief. -550. In the year 2009, what is the difference between the Number of days in Central Europe and Number of days in Costa Rica?
Offer a very short reply. -273.64. In the year 2009, what is the difference between the Number of days in Central Europe and Number of days in Equatorial Guinea?
Keep it short and to the point. 103.36. In the year 2009, what is the difference between the Number of days of Central Europe and Number of days of Nepal?
Your response must be concise. -446.64. In the year 2009, what is the difference between the Number of days of Costa Rica and Number of days of Equatorial Guinea?
Make the answer very short. 377. In the year 2009, what is the difference between the Number of days in Costa Rica and Number of days in Nepal?
Give a very brief answer. -173. In the year 2009, what is the difference between the Number of days of Equatorial Guinea and Number of days of Nepal?
Keep it short and to the point. -550. In the year 2010, what is the difference between the Number of days in Central Europe and Number of days in Costa Rica?
Keep it short and to the point. -273.64. In the year 2010, what is the difference between the Number of days of Central Europe and Number of days of Equatorial Guinea?
Offer a very short reply. 103.36. In the year 2010, what is the difference between the Number of days in Central Europe and Number of days in Nepal?
Make the answer very short. -446.64. In the year 2010, what is the difference between the Number of days in Costa Rica and Number of days in Equatorial Guinea?
Provide a short and direct response. 377. In the year 2010, what is the difference between the Number of days in Costa Rica and Number of days in Nepal?
Offer a terse response. -173. In the year 2010, what is the difference between the Number of days of Equatorial Guinea and Number of days of Nepal?
Give a very brief answer. -550. In the year 2011, what is the difference between the Number of days of Central Europe and Number of days of Costa Rica?
Your answer should be compact. -268.18. In the year 2011, what is the difference between the Number of days in Central Europe and Number of days in Equatorial Guinea?
Your response must be concise. 108.82. In the year 2011, what is the difference between the Number of days in Central Europe and Number of days in Nepal?
Your answer should be very brief. -326.18. In the year 2011, what is the difference between the Number of days of Costa Rica and Number of days of Equatorial Guinea?
Offer a very short reply. 377. In the year 2011, what is the difference between the Number of days of Costa Rica and Number of days of Nepal?
Offer a terse response. -58. In the year 2011, what is the difference between the Number of days of Equatorial Guinea and Number of days of Nepal?
Your answer should be compact. -435. In the year 2012, what is the difference between the Number of days of Central Europe and Number of days of Costa Rica?
Offer a very short reply. -273.09. In the year 2012, what is the difference between the Number of days of Central Europe and Number of days of Equatorial Guinea?
Offer a very short reply. 103.91. In the year 2012, what is the difference between the Number of days in Central Europe and Number of days in Nepal?
Make the answer very short. -331.09. In the year 2012, what is the difference between the Number of days of Costa Rica and Number of days of Equatorial Guinea?
Your answer should be very brief. 377. In the year 2012, what is the difference between the Number of days in Costa Rica and Number of days in Nepal?
Provide a succinct answer. -58. In the year 2012, what is the difference between the Number of days of Equatorial Guinea and Number of days of Nepal?
Make the answer very short. -435. In the year 2013, what is the difference between the Number of days of Central Europe and Number of days of Costa Rica?
Your answer should be compact. -274.91. In the year 2013, what is the difference between the Number of days of Central Europe and Number of days of Equatorial Guinea?
Provide a short and direct response. 102.09. In the year 2013, what is the difference between the Number of days of Central Europe and Number of days of Nepal?
Your answer should be very brief. -332.91. In the year 2013, what is the difference between the Number of days in Costa Rica and Number of days in Equatorial Guinea?
Your answer should be compact. 377. In the year 2013, what is the difference between the Number of days in Costa Rica and Number of days in Nepal?
Your response must be concise. -58. In the year 2013, what is the difference between the Number of days in Equatorial Guinea and Number of days in Nepal?
Your answer should be compact. -435. In the year 2014, what is the difference between the Number of days in Central Europe and Number of days in Costa Rica?
Your answer should be very brief. -260.36. In the year 2014, what is the difference between the Number of days in Central Europe and Number of days in Equatorial Guinea?
Ensure brevity in your answer.  116.64. In the year 2014, what is the difference between the Number of days in Central Europe and Number of days in Nepal?
Offer a very short reply. -318.36. In the year 2014, what is the difference between the Number of days of Costa Rica and Number of days of Equatorial Guinea?
Your answer should be very brief. 377. In the year 2014, what is the difference between the Number of days in Costa Rica and Number of days in Nepal?
Give a very brief answer. -58. In the year 2014, what is the difference between the Number of days in Equatorial Guinea and Number of days in Nepal?
Offer a terse response. -435. In the year 2015, what is the difference between the Number of days of Central Europe and Number of days of Costa Rica?
Ensure brevity in your answer.  -270.36. In the year 2015, what is the difference between the Number of days in Central Europe and Number of days in Equatorial Guinea?
Offer a very short reply. 106.64. In the year 2015, what is the difference between the Number of days in Central Europe and Number of days in Nepal?
Offer a very short reply. -328.36. In the year 2015, what is the difference between the Number of days in Costa Rica and Number of days in Equatorial Guinea?
Provide a succinct answer. 377. In the year 2015, what is the difference between the Number of days of Costa Rica and Number of days of Nepal?
Offer a terse response. -58. In the year 2015, what is the difference between the Number of days of Equatorial Guinea and Number of days of Nepal?
Give a very brief answer. -435. What is the ratio of the Number of days in Central Europe in 2008 to that in 2009?
Your answer should be very brief. 0.99. What is the ratio of the Number of days in Costa Rica in 2008 to that in 2009?
Offer a very short reply. 1.03. What is the ratio of the Number of days of Central Europe in 2008 to that in 2010?
Keep it short and to the point. 0.99. What is the ratio of the Number of days in Costa Rica in 2008 to that in 2010?
Your answer should be very brief. 1.03. What is the ratio of the Number of days in Equatorial Guinea in 2008 to that in 2010?
Your answer should be compact. 1. What is the ratio of the Number of days of Central Europe in 2008 to that in 2011?
Ensure brevity in your answer.  0.98. What is the ratio of the Number of days of Costa Rica in 2008 to that in 2011?
Your answer should be compact. 1.03. What is the ratio of the Number of days of Equatorial Guinea in 2008 to that in 2011?
Offer a very short reply. 1. What is the ratio of the Number of days of Nepal in 2008 to that in 2011?
Your answer should be compact. 1.13. What is the ratio of the Number of days of Costa Rica in 2008 to that in 2012?
Ensure brevity in your answer.  1.03. What is the ratio of the Number of days of Nepal in 2008 to that in 2012?
Offer a terse response. 1.13. What is the ratio of the Number of days in Central Europe in 2008 to that in 2013?
Your answer should be very brief. 0.99. What is the ratio of the Number of days of Costa Rica in 2008 to that in 2013?
Give a very brief answer. 1.03. What is the ratio of the Number of days of Equatorial Guinea in 2008 to that in 2013?
Offer a terse response. 1. What is the ratio of the Number of days in Nepal in 2008 to that in 2013?
Your answer should be very brief. 1.13. What is the ratio of the Number of days in Central Europe in 2008 to that in 2014?
Provide a succinct answer. 0.97. What is the ratio of the Number of days in Costa Rica in 2008 to that in 2014?
Offer a very short reply. 1.03. What is the ratio of the Number of days in Equatorial Guinea in 2008 to that in 2014?
Keep it short and to the point. 1. What is the ratio of the Number of days of Nepal in 2008 to that in 2014?
Offer a terse response. 1.13. What is the ratio of the Number of days of Central Europe in 2008 to that in 2015?
Ensure brevity in your answer.  0.98. What is the ratio of the Number of days of Costa Rica in 2008 to that in 2015?
Provide a short and direct response. 1.03. What is the ratio of the Number of days of Equatorial Guinea in 2008 to that in 2015?
Keep it short and to the point. 1. What is the ratio of the Number of days of Nepal in 2008 to that in 2015?
Offer a very short reply. 1.13. What is the ratio of the Number of days in Costa Rica in 2009 to that in 2010?
Your response must be concise. 1. What is the ratio of the Number of days of Equatorial Guinea in 2009 to that in 2010?
Provide a succinct answer. 1. What is the ratio of the Number of days of Nepal in 2009 to that in 2010?
Your response must be concise. 1. What is the ratio of the Number of days of Central Europe in 2009 to that in 2011?
Offer a very short reply. 0.99. What is the ratio of the Number of days in Costa Rica in 2009 to that in 2011?
Provide a short and direct response. 1. What is the ratio of the Number of days of Nepal in 2009 to that in 2011?
Your answer should be compact. 1.13. What is the ratio of the Number of days in Equatorial Guinea in 2009 to that in 2012?
Offer a very short reply. 1. What is the ratio of the Number of days of Nepal in 2009 to that in 2012?
Offer a terse response. 1.13. What is the ratio of the Number of days in Central Europe in 2009 to that in 2013?
Offer a very short reply. 1. What is the ratio of the Number of days of Costa Rica in 2009 to that in 2013?
Give a very brief answer. 1. What is the ratio of the Number of days in Equatorial Guinea in 2009 to that in 2013?
Offer a terse response. 1. What is the ratio of the Number of days of Nepal in 2009 to that in 2013?
Ensure brevity in your answer.  1.13. What is the ratio of the Number of days of Central Europe in 2009 to that in 2014?
Your response must be concise. 0.98. What is the ratio of the Number of days in Nepal in 2009 to that in 2014?
Your response must be concise. 1.13. What is the ratio of the Number of days in Costa Rica in 2009 to that in 2015?
Your response must be concise. 1. What is the ratio of the Number of days of Equatorial Guinea in 2009 to that in 2015?
Your answer should be compact. 1. What is the ratio of the Number of days of Nepal in 2009 to that in 2015?
Keep it short and to the point. 1.13. What is the ratio of the Number of days in Costa Rica in 2010 to that in 2011?
Ensure brevity in your answer.  1. What is the ratio of the Number of days of Nepal in 2010 to that in 2011?
Your answer should be very brief. 1.13. What is the ratio of the Number of days in Central Europe in 2010 to that in 2012?
Provide a succinct answer. 1. What is the ratio of the Number of days in Nepal in 2010 to that in 2012?
Your answer should be very brief. 1.13. What is the ratio of the Number of days in Nepal in 2010 to that in 2013?
Offer a very short reply. 1.13. What is the ratio of the Number of days in Central Europe in 2010 to that in 2014?
Your answer should be very brief. 0.98. What is the ratio of the Number of days in Costa Rica in 2010 to that in 2014?
Offer a very short reply. 1. What is the ratio of the Number of days of Nepal in 2010 to that in 2014?
Keep it short and to the point. 1.13. What is the ratio of the Number of days in Nepal in 2010 to that in 2015?
Keep it short and to the point. 1.13. What is the ratio of the Number of days in Central Europe in 2011 to that in 2012?
Your answer should be compact. 1.01. What is the ratio of the Number of days of Costa Rica in 2011 to that in 2012?
Offer a terse response. 1. What is the ratio of the Number of days of Equatorial Guinea in 2011 to that in 2012?
Offer a terse response. 1. What is the ratio of the Number of days in Nepal in 2011 to that in 2012?
Your answer should be very brief. 1. What is the ratio of the Number of days of Central Europe in 2011 to that in 2013?
Keep it short and to the point. 1.01. What is the ratio of the Number of days in Costa Rica in 2011 to that in 2013?
Your response must be concise. 1. What is the ratio of the Number of days in Equatorial Guinea in 2011 to that in 2013?
Keep it short and to the point. 1. What is the ratio of the Number of days of Nepal in 2011 to that in 2013?
Offer a very short reply. 1. What is the ratio of the Number of days in Costa Rica in 2011 to that in 2014?
Offer a terse response. 1. What is the ratio of the Number of days in Equatorial Guinea in 2011 to that in 2015?
Make the answer very short. 1. What is the ratio of the Number of days of Nepal in 2011 to that in 2015?
Your answer should be compact. 1. What is the ratio of the Number of days in Costa Rica in 2012 to that in 2013?
Offer a very short reply. 1. What is the ratio of the Number of days of Equatorial Guinea in 2012 to that in 2013?
Your answer should be compact. 1. What is the ratio of the Number of days of Central Europe in 2012 to that in 2014?
Your answer should be very brief. 0.98. What is the ratio of the Number of days in Equatorial Guinea in 2012 to that in 2014?
Keep it short and to the point. 1. What is the ratio of the Number of days in Nepal in 2012 to that in 2014?
Make the answer very short. 1. What is the ratio of the Number of days of Costa Rica in 2012 to that in 2015?
Offer a very short reply. 1. What is the ratio of the Number of days of Equatorial Guinea in 2012 to that in 2015?
Provide a short and direct response. 1. What is the ratio of the Number of days of Nepal in 2012 to that in 2015?
Provide a short and direct response. 1. What is the ratio of the Number of days in Central Europe in 2013 to that in 2014?
Your answer should be very brief. 0.98. What is the ratio of the Number of days in Equatorial Guinea in 2013 to that in 2014?
Offer a terse response. 1. What is the ratio of the Number of days of Nepal in 2013 to that in 2014?
Your response must be concise. 1. What is the ratio of the Number of days in Costa Rica in 2013 to that in 2015?
Give a very brief answer. 1. What is the ratio of the Number of days in Equatorial Guinea in 2013 to that in 2015?
Offer a very short reply. 1. What is the ratio of the Number of days in Nepal in 2013 to that in 2015?
Your response must be concise. 1. What is the ratio of the Number of days of Central Europe in 2014 to that in 2015?
Provide a succinct answer. 1.02. What is the difference between the highest and the second highest Number of days of Central Europe?
Your answer should be very brief. 7.82. What is the difference between the highest and the second highest Number of days in Costa Rica?
Make the answer very short. 25. What is the difference between the highest and the second highest Number of days of Equatorial Guinea?
Offer a terse response. 0. What is the difference between the highest and the second highest Number of days of Nepal?
Ensure brevity in your answer.  0. What is the difference between the highest and the lowest Number of days of Central Europe?
Give a very brief answer. 20.36. What is the difference between the highest and the lowest Number of days in Equatorial Guinea?
Provide a succinct answer. 0. What is the difference between the highest and the lowest Number of days in Nepal?
Your response must be concise. 115. 